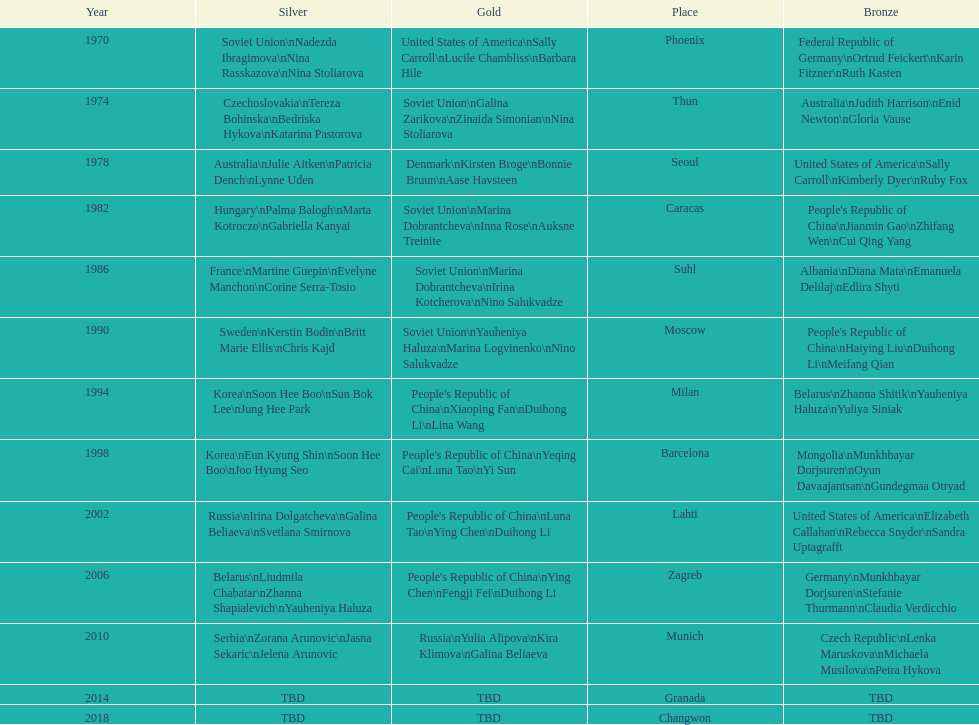What are the total number of times the soviet union is listed under the gold column? 4. 